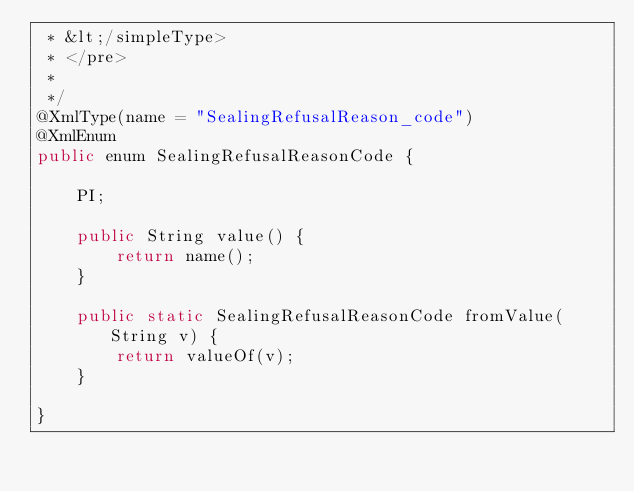<code> <loc_0><loc_0><loc_500><loc_500><_Java_> * &lt;/simpleType>
 * </pre>
 * 
 */
@XmlType(name = "SealingRefusalReason_code")
@XmlEnum
public enum SealingRefusalReasonCode {

    PI;

    public String value() {
        return name();
    }

    public static SealingRefusalReasonCode fromValue(String v) {
        return valueOf(v);
    }

}
</code> 